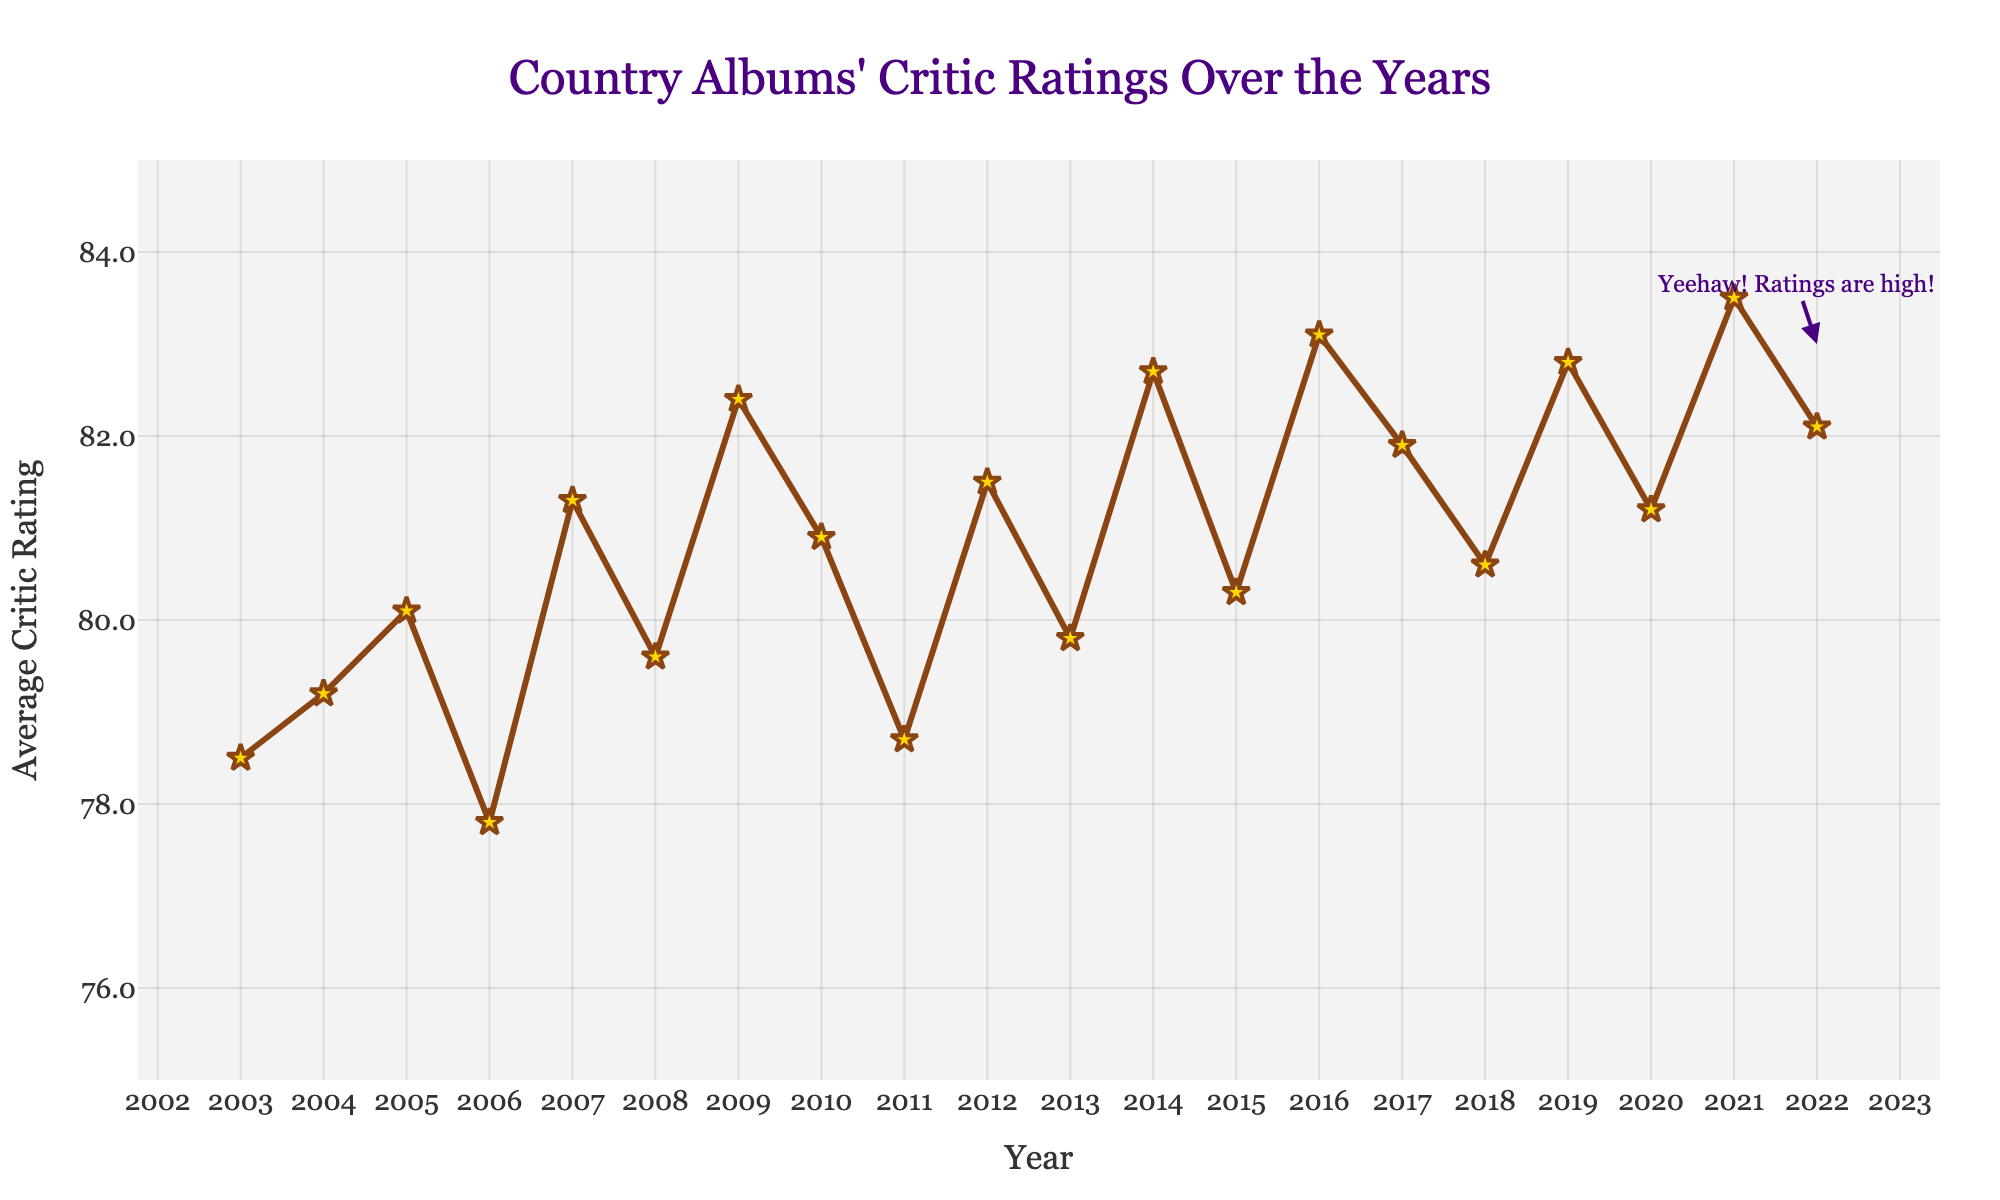Which year had the highest average critic rating? By looking at the highest point on the line chart, we can see that the peak occurs at the year 2021.
Answer: 2021 How much did the average critic rating increase from 2003 to 2022? The average critic rating in 2003 was 78.5 and in 2022 it was 82.1. The increase is 82.1 - 78.5, which equals 3.6.
Answer: 3.6 Which year had a lower average critic rating: 2006 or 2011? By comparing the points on the chart for 2006 and 2011, we see that 2006 has a rating of 77.8 and 2011 has a rating of 78.7. Consequently, 2006 had a lower rating.
Answer: 2006 From 2014 to 2016, did the average critic rating trend upward or downward? We need to look at the trend from 2014 to 2016. For these years, the ratings are 82.7 (2014), 80.3 (2015), and 83.1 (2016). This shows an upward trend from 2015 to 2016, after a drop from 2014 to 2015.
Answer: Upward Which period had the biggest drop in the average critic rating? You need to visually identify the steepest downward slope on the line chart. The biggest drop happened between 2014 (82.7) to 2015 (80.3), a decrease of 2.4.
Answer: 2014 to 2015 What was the average critic rating for the years 2010, 2011, and 2012? We need to find the sum of the ratings for these years and then divide by 3. The ratings are 80.9 (2010), 78.7 (2011), and 81.5 (2012). The sum is 80.9 + 78.7 + 81.5 = 241.1. So, the average is 241.1 / 3 ≈ 80.37.
Answer: 80.37 Did the average critic rating ever exceed 83 after 2013? We need to locate any points above 83 on the line chart after the year 2013. This happens in 2016 (83.1) and 2021 (83.5).
Answer: Yes What is the difference between the highest and lowest average critic ratings in the data? The highest rating is 83.5 (2021) and the lowest is 77.8 (2006). The difference is 83.5 - 77.8 = 5.7.
Answer: 5.7 How did the critic ratings trend from 2018 to 2020? Evaluating the points from 2018 (80.6), 2019 (82.8), and 2020 (81.2) shows an initial increase from 2018 to 2019, followed by a slight decrease in 2020.
Answer: Upward then downward 